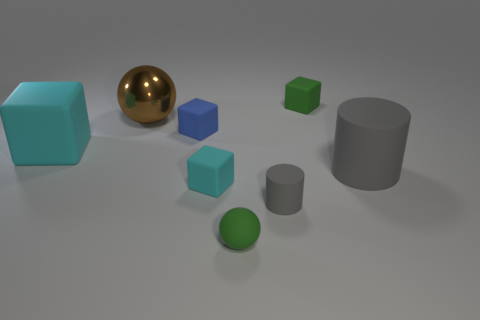Are there any other things that have the same material as the large brown sphere?
Give a very brief answer. No. How many large cyan things have the same material as the blue thing?
Your answer should be compact. 1. There is a tiny object that is the same color as the rubber ball; what is its shape?
Make the answer very short. Cube. What size is the gray cylinder that is in front of the cyan block in front of the large block?
Provide a short and direct response. Small. Is the shape of the large cyan matte thing in front of the big brown shiny sphere the same as the big object to the right of the big brown metallic object?
Your answer should be compact. No. Is the number of matte balls on the left side of the blue matte cube the same as the number of small gray matte cylinders?
Your answer should be very brief. No. The other object that is the same shape as the tiny gray thing is what color?
Ensure brevity in your answer.  Gray. Are the brown ball behind the small blue rubber thing and the green cube made of the same material?
Offer a terse response. No. How many small objects are either cyan rubber things or cyan cylinders?
Give a very brief answer. 1. The green block is what size?
Your response must be concise. Small. 